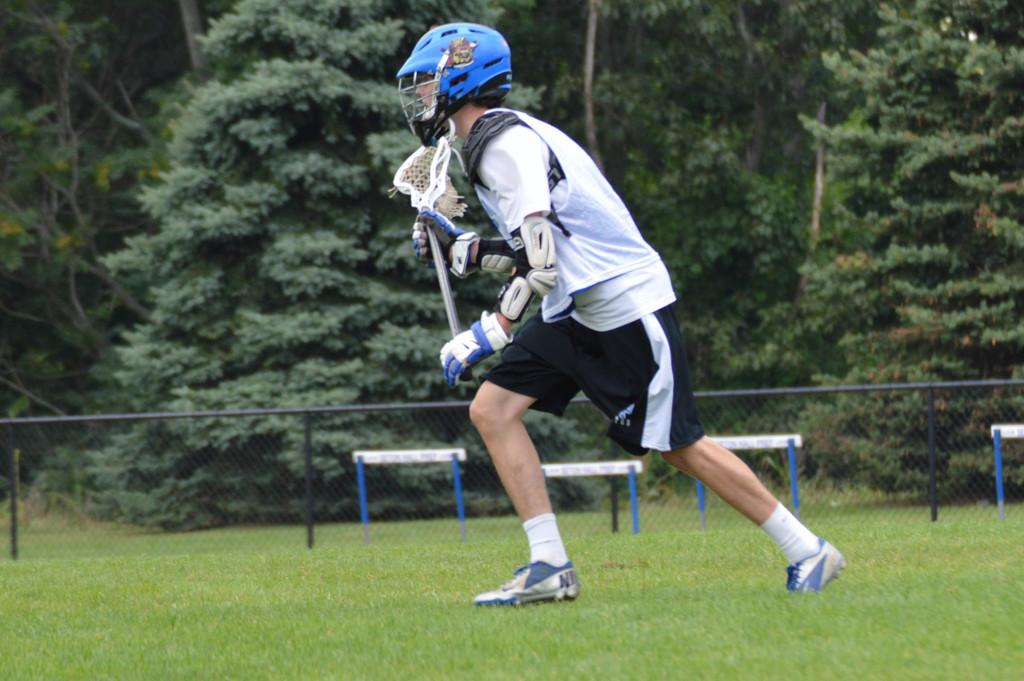Who or what is present in the image? There is a person in the image. What is the person's position in the image? The person is on the ground. What protective gear is the person wearing? The person is wearing a helmet. What is the person holding in the image? The person is holding an object. What structures can be seen in the background of the image? There is a fence and hurdles in the image. What type of natural environment is visible in the image? There are trees in the image. What book is the person reading in the image? There is no book or reading activity present in the image. How many balls can be seen in the image? There are no balls visible in the image. 